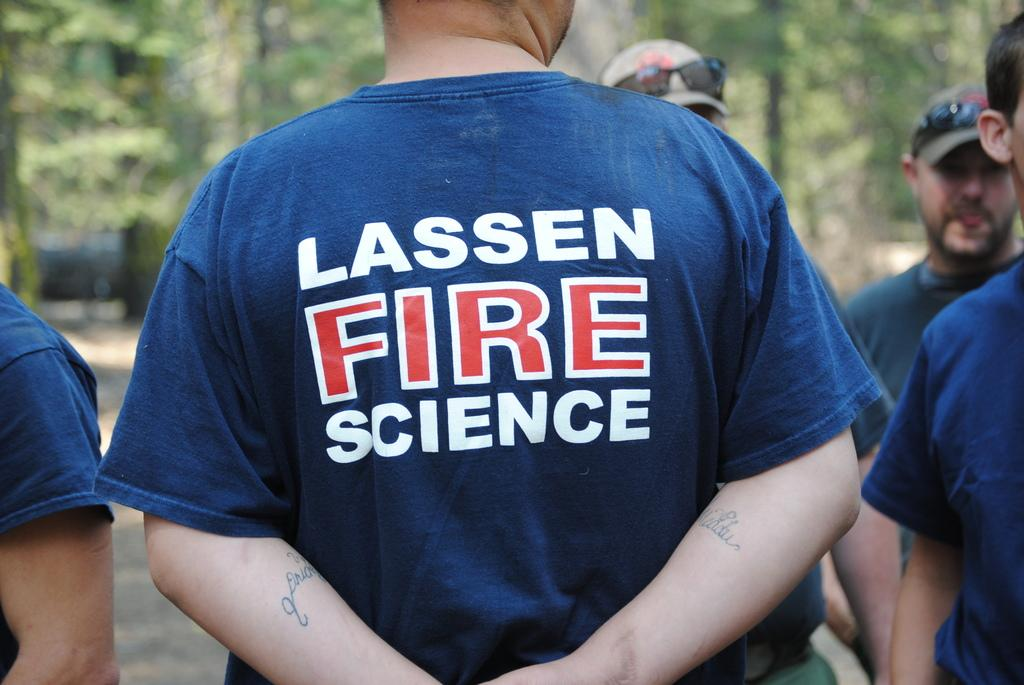<image>
Render a clear and concise summary of the photo. A man stands with his arms behind his back wearing a Lassen Fire Science shirt. 